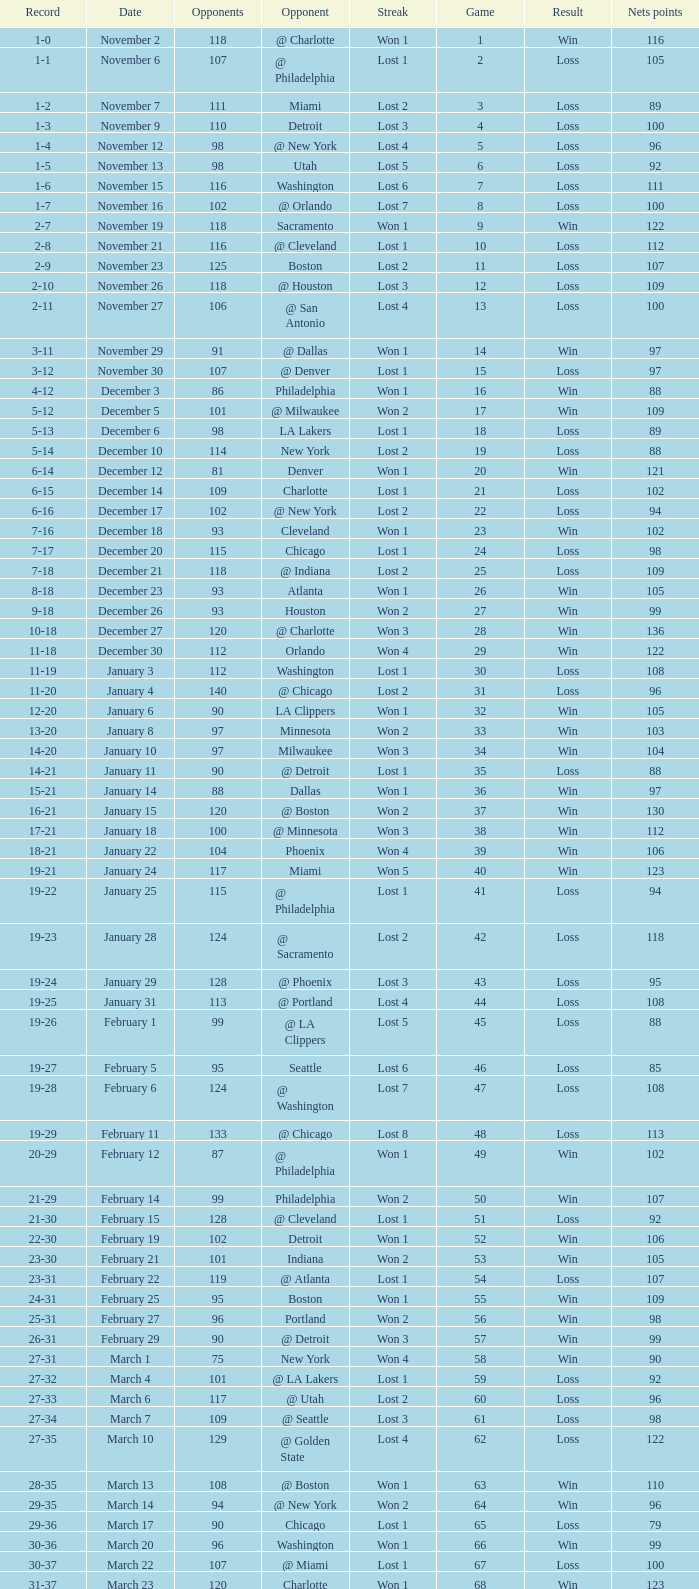How many games had fewer than 118 opponents and more than 109 net points with an opponent of Washington? 1.0. 